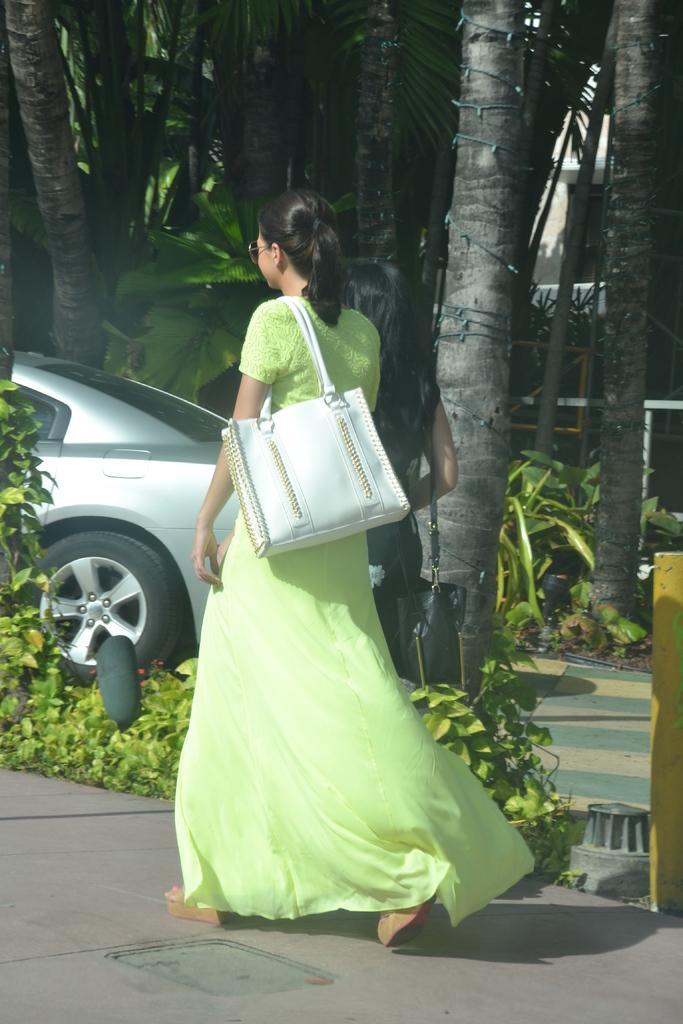In one or two sentences, can you explain what this image depicts? In this image I can see a woman in green dress is standing, I can also see she is carrying a bag. In the background I can see number of trees, plants and a vehicle. 